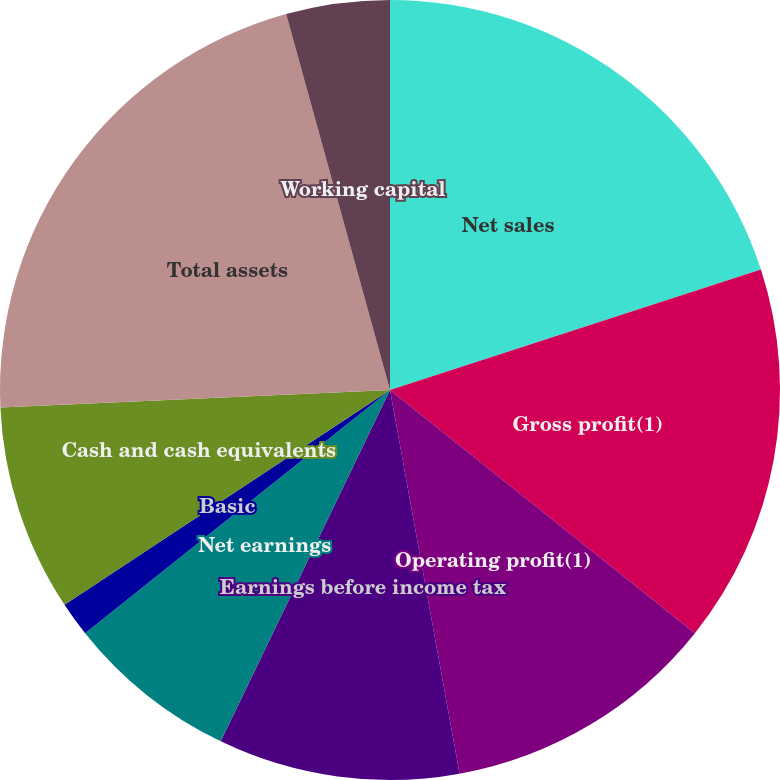Convert chart. <chart><loc_0><loc_0><loc_500><loc_500><pie_chart><fcel>Net sales<fcel>Gross profit(1)<fcel>Operating profit(1)<fcel>Earnings before income tax<fcel>Net earnings<fcel>Basic<fcel>Diluted<fcel>Cash and cash equivalents<fcel>Total assets<fcel>Working capital<nl><fcel>20.0%<fcel>15.71%<fcel>11.43%<fcel>10.0%<fcel>7.14%<fcel>1.43%<fcel>0.0%<fcel>8.57%<fcel>21.42%<fcel>4.29%<nl></chart> 